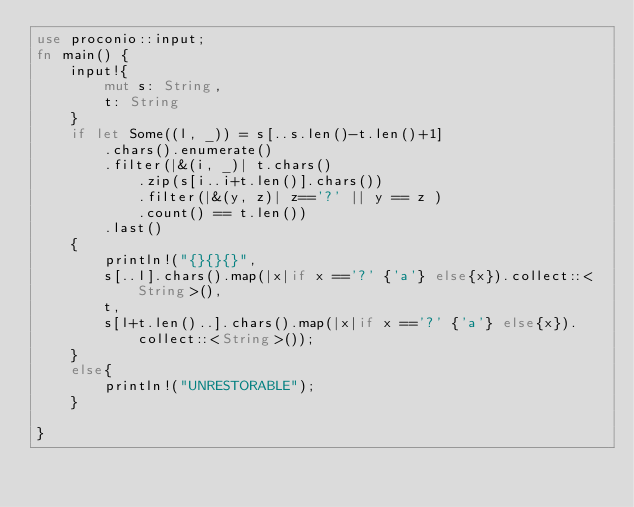<code> <loc_0><loc_0><loc_500><loc_500><_Rust_>use proconio::input;
fn main() {
    input!{
        mut s: String,
        t: String
    }
    if let Some((l, _)) = s[..s.len()-t.len()+1]
        .chars().enumerate()
        .filter(|&(i, _)| t.chars()
            .zip(s[i..i+t.len()].chars())
            .filter(|&(y, z)| z=='?' || y == z )
            .count() == t.len())
        .last()
    {   
        println!("{}{}{}", 
        s[..l].chars().map(|x|if x =='?' {'a'} else{x}).collect::<String>(),
        t,
        s[l+t.len()..].chars().map(|x|if x =='?' {'a'} else{x}).collect::<String>());
    }
    else{
        println!("UNRESTORABLE");
    }
    
}



</code> 